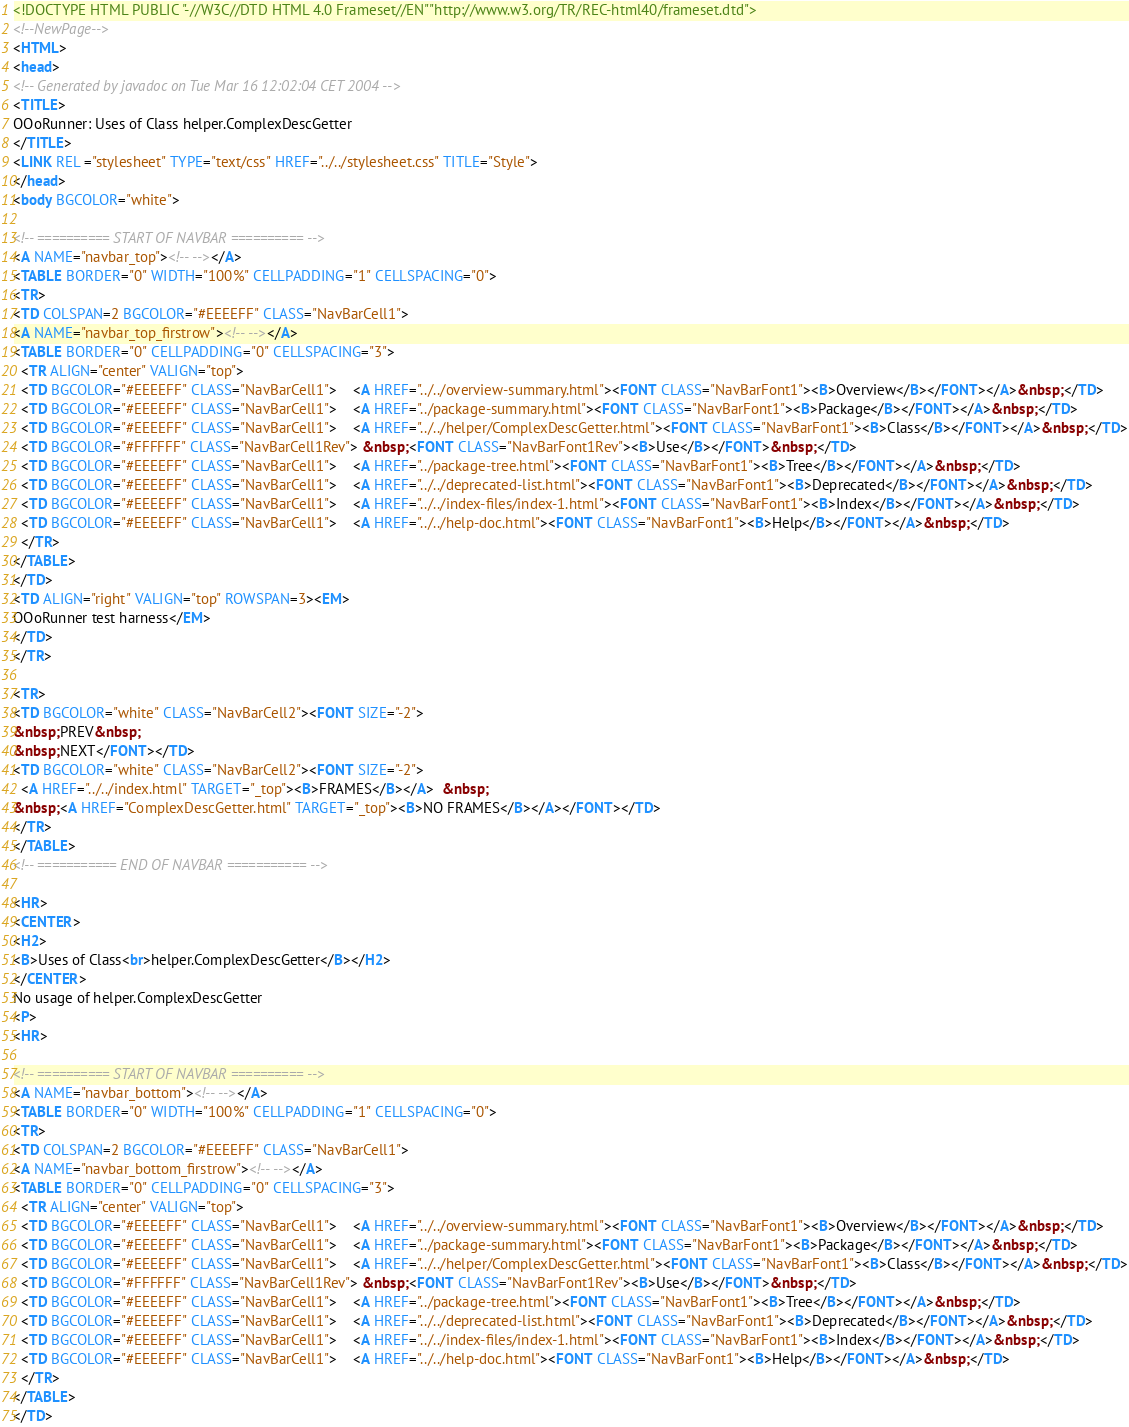Convert code to text. <code><loc_0><loc_0><loc_500><loc_500><_HTML_><!DOCTYPE HTML PUBLIC "-//W3C//DTD HTML 4.0 Frameset//EN""http://www.w3.org/TR/REC-html40/frameset.dtd">
<!--NewPage-->
<HTML>
<head>
<!-- Generated by javadoc on Tue Mar 16 12:02:04 CET 2004 -->
<TITLE>
OOoRunner: Uses of Class helper.ComplexDescGetter
</TITLE>
<LINK REL ="stylesheet" TYPE="text/css" HREF="../../stylesheet.css" TITLE="Style">
</head>
<body BGCOLOR="white">

<!-- ========== START OF NAVBAR ========== -->
<A NAME="navbar_top"><!-- --></A>
<TABLE BORDER="0" WIDTH="100%" CELLPADDING="1" CELLSPACING="0">
<TR>
<TD COLSPAN=2 BGCOLOR="#EEEEFF" CLASS="NavBarCell1">
<A NAME="navbar_top_firstrow"><!-- --></A>
<TABLE BORDER="0" CELLPADDING="0" CELLSPACING="3">
  <TR ALIGN="center" VALIGN="top">
  <TD BGCOLOR="#EEEEFF" CLASS="NavBarCell1">    <A HREF="../../overview-summary.html"><FONT CLASS="NavBarFont1"><B>Overview</B></FONT></A>&nbsp;</TD>
  <TD BGCOLOR="#EEEEFF" CLASS="NavBarCell1">    <A HREF="../package-summary.html"><FONT CLASS="NavBarFont1"><B>Package</B></FONT></A>&nbsp;</TD>
  <TD BGCOLOR="#EEEEFF" CLASS="NavBarCell1">    <A HREF="../../helper/ComplexDescGetter.html"><FONT CLASS="NavBarFont1"><B>Class</B></FONT></A>&nbsp;</TD>
  <TD BGCOLOR="#FFFFFF" CLASS="NavBarCell1Rev"> &nbsp;<FONT CLASS="NavBarFont1Rev"><B>Use</B></FONT>&nbsp;</TD>
  <TD BGCOLOR="#EEEEFF" CLASS="NavBarCell1">    <A HREF="../package-tree.html"><FONT CLASS="NavBarFont1"><B>Tree</B></FONT></A>&nbsp;</TD>
  <TD BGCOLOR="#EEEEFF" CLASS="NavBarCell1">    <A HREF="../../deprecated-list.html"><FONT CLASS="NavBarFont1"><B>Deprecated</B></FONT></A>&nbsp;</TD>
  <TD BGCOLOR="#EEEEFF" CLASS="NavBarCell1">    <A HREF="../../index-files/index-1.html"><FONT CLASS="NavBarFont1"><B>Index</B></FONT></A>&nbsp;</TD>
  <TD BGCOLOR="#EEEEFF" CLASS="NavBarCell1">    <A HREF="../../help-doc.html"><FONT CLASS="NavBarFont1"><B>Help</B></FONT></A>&nbsp;</TD>
  </TR>
</TABLE>
</TD>
<TD ALIGN="right" VALIGN="top" ROWSPAN=3><EM>
OOoRunner test harness</EM>
</TD>
</TR>

<TR>
<TD BGCOLOR="white" CLASS="NavBarCell2"><FONT SIZE="-2">
&nbsp;PREV&nbsp;
&nbsp;NEXT</FONT></TD>
<TD BGCOLOR="white" CLASS="NavBarCell2"><FONT SIZE="-2">
  <A HREF="../../index.html" TARGET="_top"><B>FRAMES</B></A>  &nbsp;
&nbsp;<A HREF="ComplexDescGetter.html" TARGET="_top"><B>NO FRAMES</B></A></FONT></TD>
</TR>
</TABLE>
<!-- =========== END OF NAVBAR =========== -->

<HR>
<CENTER>
<H2>
<B>Uses of Class<br>helper.ComplexDescGetter</B></H2>
</CENTER>
No usage of helper.ComplexDescGetter
<P>
<HR>

<!-- ========== START OF NAVBAR ========== -->
<A NAME="navbar_bottom"><!-- --></A>
<TABLE BORDER="0" WIDTH="100%" CELLPADDING="1" CELLSPACING="0">
<TR>
<TD COLSPAN=2 BGCOLOR="#EEEEFF" CLASS="NavBarCell1">
<A NAME="navbar_bottom_firstrow"><!-- --></A>
<TABLE BORDER="0" CELLPADDING="0" CELLSPACING="3">
  <TR ALIGN="center" VALIGN="top">
  <TD BGCOLOR="#EEEEFF" CLASS="NavBarCell1">    <A HREF="../../overview-summary.html"><FONT CLASS="NavBarFont1"><B>Overview</B></FONT></A>&nbsp;</TD>
  <TD BGCOLOR="#EEEEFF" CLASS="NavBarCell1">    <A HREF="../package-summary.html"><FONT CLASS="NavBarFont1"><B>Package</B></FONT></A>&nbsp;</TD>
  <TD BGCOLOR="#EEEEFF" CLASS="NavBarCell1">    <A HREF="../../helper/ComplexDescGetter.html"><FONT CLASS="NavBarFont1"><B>Class</B></FONT></A>&nbsp;</TD>
  <TD BGCOLOR="#FFFFFF" CLASS="NavBarCell1Rev"> &nbsp;<FONT CLASS="NavBarFont1Rev"><B>Use</B></FONT>&nbsp;</TD>
  <TD BGCOLOR="#EEEEFF" CLASS="NavBarCell1">    <A HREF="../package-tree.html"><FONT CLASS="NavBarFont1"><B>Tree</B></FONT></A>&nbsp;</TD>
  <TD BGCOLOR="#EEEEFF" CLASS="NavBarCell1">    <A HREF="../../deprecated-list.html"><FONT CLASS="NavBarFont1"><B>Deprecated</B></FONT></A>&nbsp;</TD>
  <TD BGCOLOR="#EEEEFF" CLASS="NavBarCell1">    <A HREF="../../index-files/index-1.html"><FONT CLASS="NavBarFont1"><B>Index</B></FONT></A>&nbsp;</TD>
  <TD BGCOLOR="#EEEEFF" CLASS="NavBarCell1">    <A HREF="../../help-doc.html"><FONT CLASS="NavBarFont1"><B>Help</B></FONT></A>&nbsp;</TD>
  </TR>
</TABLE>
</TD></code> 